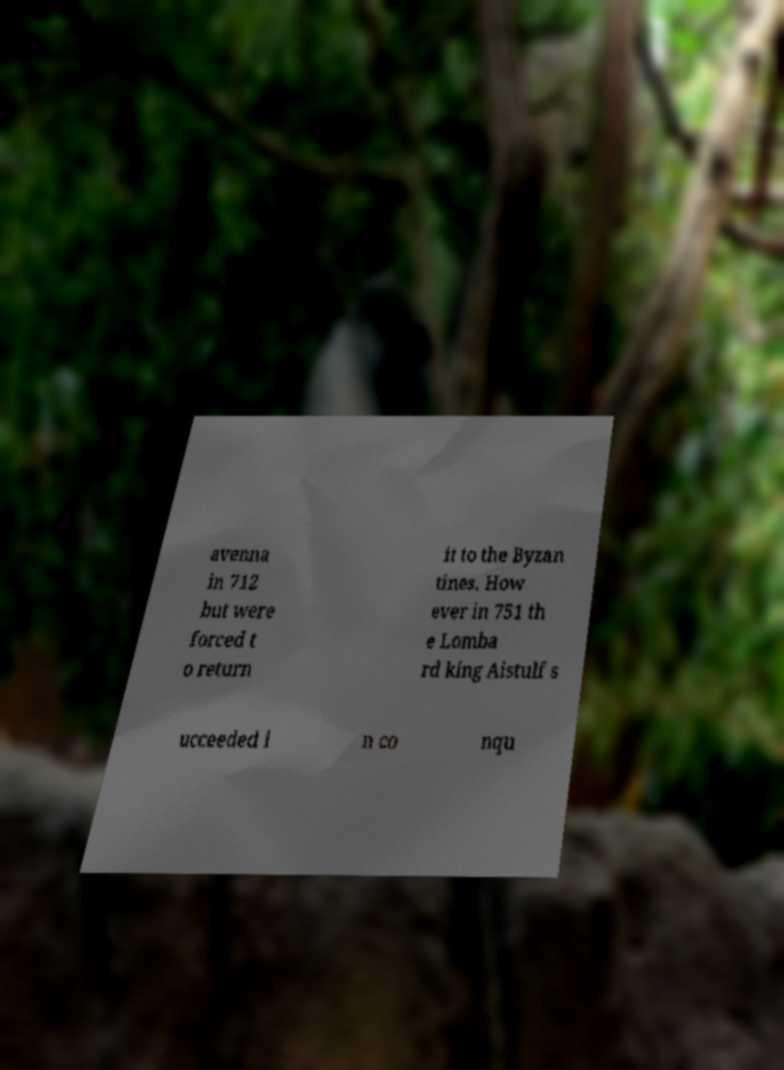Could you assist in decoding the text presented in this image and type it out clearly? avenna in 712 but were forced t o return it to the Byzan tines. How ever in 751 th e Lomba rd king Aistulf s ucceeded i n co nqu 